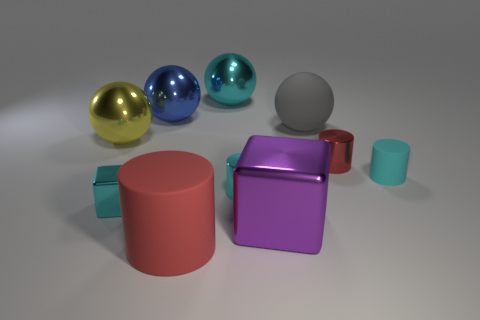Do the purple metal thing and the tiny matte object have the same shape?
Your answer should be very brief. No. How many big blue balls are to the left of the cube that is on the right side of the blue object?
Keep it short and to the point. 1. There is a yellow thing that is the same shape as the big cyan shiny object; what is its material?
Your answer should be compact. Metal. There is a matte object to the right of the big gray matte ball; does it have the same color as the tiny cube?
Give a very brief answer. Yes. Are the purple cube and the red cylinder that is behind the large red rubber cylinder made of the same material?
Your answer should be very brief. Yes. There is a small shiny object that is right of the purple block; what is its shape?
Your answer should be very brief. Cylinder. How many other objects are there of the same material as the big red object?
Provide a succinct answer. 2. What size is the red metal cylinder?
Provide a short and direct response. Small. How many other objects are the same color as the matte ball?
Offer a terse response. 0. What color is the large shiny object that is to the left of the large red rubber object and to the right of the large yellow metal thing?
Give a very brief answer. Blue. 